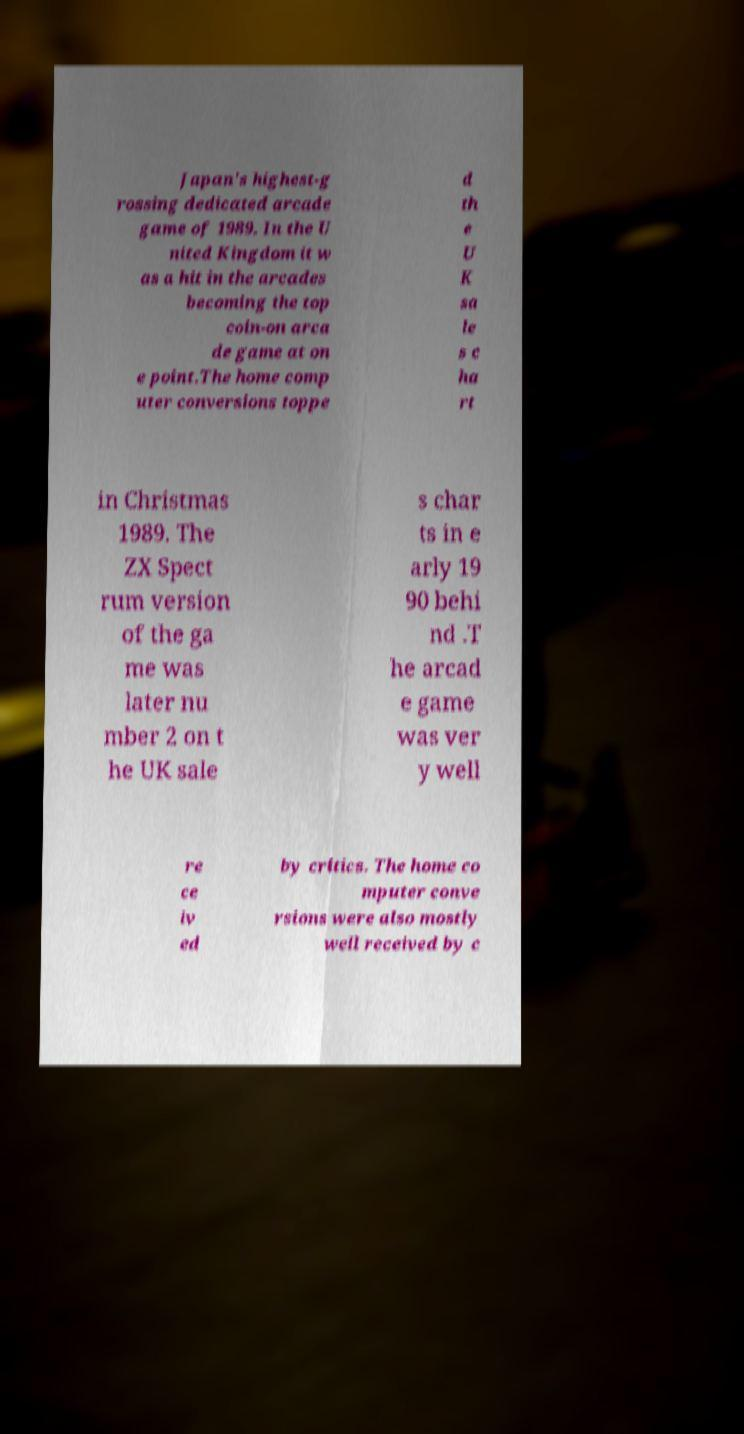There's text embedded in this image that I need extracted. Can you transcribe it verbatim? Japan's highest-g rossing dedicated arcade game of 1989. In the U nited Kingdom it w as a hit in the arcades becoming the top coin-on arca de game at on e point.The home comp uter conversions toppe d th e U K sa le s c ha rt in Christmas 1989. The ZX Spect rum version of the ga me was later nu mber 2 on t he UK sale s char ts in e arly 19 90 behi nd .T he arcad e game was ver y well re ce iv ed by critics. The home co mputer conve rsions were also mostly well received by c 